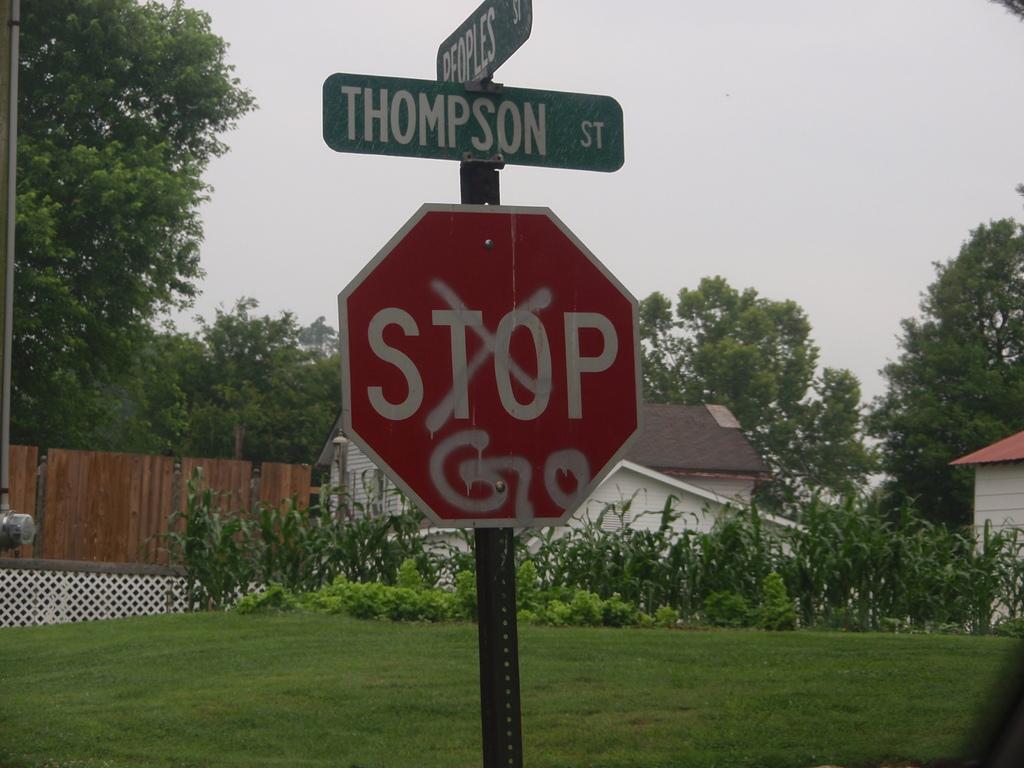Which street is this?
Your answer should be very brief. Thompson. 